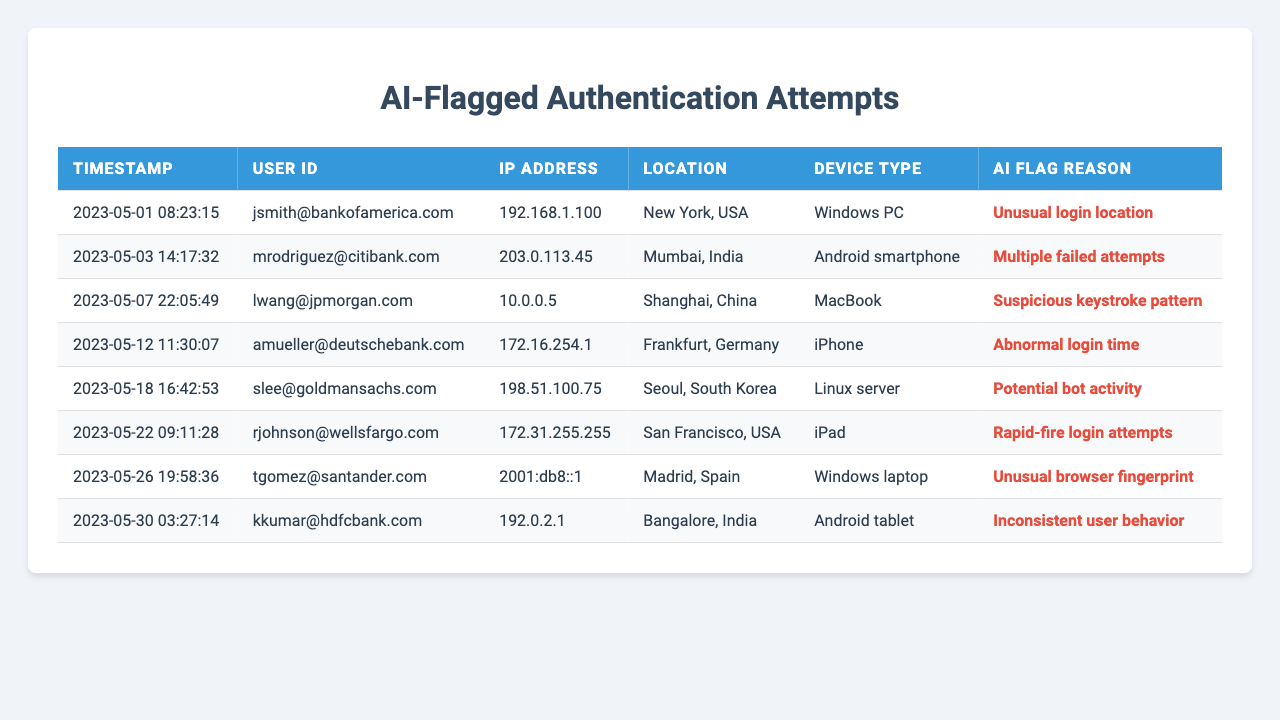What is the total number of authentication attempts flagged by AI systems in the past month? The table lists a total of 8 authentication attempts, each of which has been flagged by AI systems. Therefore, the total is simply the count of these entries.
Answer: 8 Which user had an authentication attempt flagged due to "Unusual login location"? From the table, the entry for the user "jsmith@bankofamerica.com" has the AI flag reason "Unusual login location."
Answer: jsmith@bankofamerica.com How many users experienced multiple failed authentication attempts? Looking at the table, only one user, "mrodriguez@citibank.com," has the flag reason "Multiple failed attempts." Thus, there is a single user with this issue.
Answer: 1 What type of device was used in the authentication attempt flagged for "Potential bot activity"? In the table, the entry for "slee@goldmansachs.com," which has the flag reason "Potential bot activity," shows the device type as "Linux server."
Answer: Linux server Is there any authentication attempt from a user based in Frankfurt, Germany? Yes, the entry for "amueller@deutschebank.com" indicates that the user is based in Frankfurt, Germany, as seen in the location column.
Answer: Yes How many different AI flag reasons are present in the table? The table includes 6 unique AI flag reasons: "Unusual login location," "Multiple failed attempts," "Suspicious keystroke pattern," "Abnormal login time," "Potential bot activity," and "Rapid-fire login attempts." Therefore, the count of distinct reasons adds up to 6.
Answer: 6 Which location had the most flagged authentication attempts? Analyzing the locations from the table, we see that each location has only one entry, including New York, Mumbai, Shanghai, Frankfurt, Seoul, San Francisco, Madrid, and Bangalore. Consequently, no location has more than one flagged attempt.
Answer: None What is the earliest timestamp of the authentication attempts flagged by AI? The earliest timestamp in the table is "2023-05-01 08:23:15" associated with the user "jsmith@bankofamerica.com."
Answer: 2023-05-01 08:23:15 How many flagged attempts were associated with mobile devices? From the table, we find two entries related to mobile devices: "Android smartphone" (mrodriguez@citibank.com) and "iPhone" (amueller@deutschebank.com). Hence, the total count is 2.
Answer: 2 Which AI flag reason is most frequently represented in the data? The entered reasons in the table are each represented only once, meaning there is no single most frequent reason; they are all equal in frequency.
Answer: None 